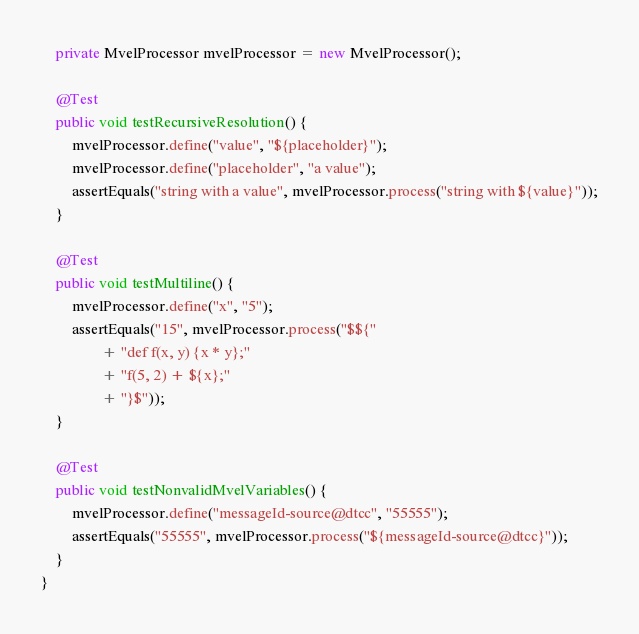<code> <loc_0><loc_0><loc_500><loc_500><_Java_>	private MvelProcessor mvelProcessor = new MvelProcessor();
	
	@Test
	public void testRecursiveResolution() {
		mvelProcessor.define("value", "${placeholder}");
		mvelProcessor.define("placeholder", "a value");
		assertEquals("string with a value", mvelProcessor.process("string with ${value}"));
	}
	
	@Test
	public void testMultiline() {
		mvelProcessor.define("x", "5");
		assertEquals("15", mvelProcessor.process("$${"
				+ "def f(x, y) {x * y};"
				+ "f(5, 2) + ${x};"
				+ "}$"));
	}
	
	@Test
	public void testNonvalidMvelVariables() {
		mvelProcessor.define("messageId-source@dtcc", "55555");
		assertEquals("55555", mvelProcessor.process("${messageId-source@dtcc}"));
	}
}
</code> 